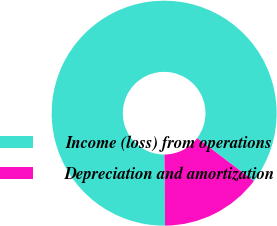Convert chart to OTSL. <chart><loc_0><loc_0><loc_500><loc_500><pie_chart><fcel>Income (loss) from operations<fcel>Depreciation and amortization<nl><fcel>85.42%<fcel>14.58%<nl></chart> 